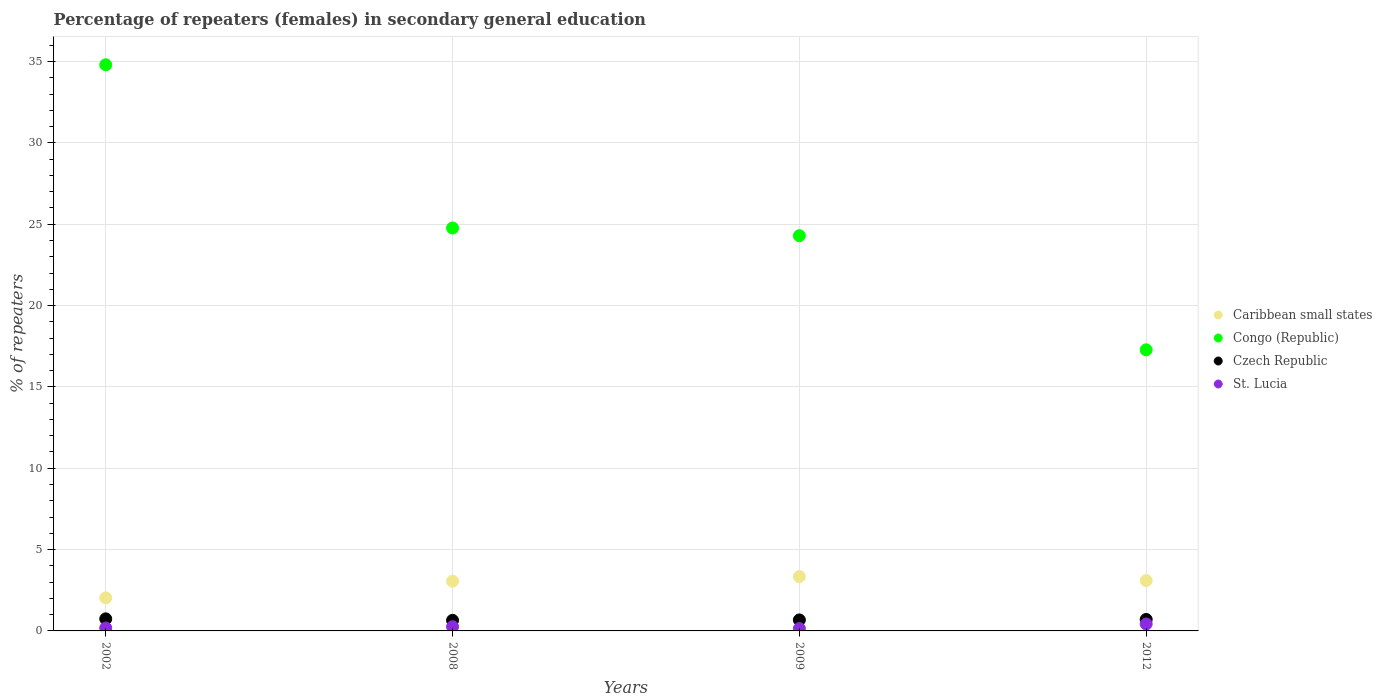How many different coloured dotlines are there?
Provide a succinct answer. 4. Is the number of dotlines equal to the number of legend labels?
Your answer should be very brief. Yes. What is the percentage of female repeaters in Czech Republic in 2012?
Your response must be concise. 0.7. Across all years, what is the maximum percentage of female repeaters in Caribbean small states?
Keep it short and to the point. 3.34. Across all years, what is the minimum percentage of female repeaters in Caribbean small states?
Make the answer very short. 2.03. What is the total percentage of female repeaters in Congo (Republic) in the graph?
Your response must be concise. 101.14. What is the difference between the percentage of female repeaters in St. Lucia in 2008 and that in 2009?
Keep it short and to the point. 0.11. What is the difference between the percentage of female repeaters in St. Lucia in 2008 and the percentage of female repeaters in Czech Republic in 2009?
Offer a terse response. -0.42. What is the average percentage of female repeaters in Czech Republic per year?
Ensure brevity in your answer.  0.69. In the year 2002, what is the difference between the percentage of female repeaters in St. Lucia and percentage of female repeaters in Czech Republic?
Keep it short and to the point. -0.56. In how many years, is the percentage of female repeaters in Czech Republic greater than 15 %?
Offer a very short reply. 0. What is the ratio of the percentage of female repeaters in Congo (Republic) in 2008 to that in 2009?
Keep it short and to the point. 1.02. Is the difference between the percentage of female repeaters in St. Lucia in 2009 and 2012 greater than the difference between the percentage of female repeaters in Czech Republic in 2009 and 2012?
Your response must be concise. No. What is the difference between the highest and the second highest percentage of female repeaters in Czech Republic?
Offer a very short reply. 0.04. What is the difference between the highest and the lowest percentage of female repeaters in Congo (Republic)?
Keep it short and to the point. 17.52. Does the percentage of female repeaters in Congo (Republic) monotonically increase over the years?
Your answer should be very brief. No. Is the percentage of female repeaters in Czech Republic strictly greater than the percentage of female repeaters in Caribbean small states over the years?
Ensure brevity in your answer.  No. Is the percentage of female repeaters in St. Lucia strictly less than the percentage of female repeaters in Caribbean small states over the years?
Your answer should be very brief. Yes. How many dotlines are there?
Offer a terse response. 4. How many years are there in the graph?
Provide a succinct answer. 4. Does the graph contain any zero values?
Offer a very short reply. No. Where does the legend appear in the graph?
Give a very brief answer. Center right. What is the title of the graph?
Your answer should be compact. Percentage of repeaters (females) in secondary general education. What is the label or title of the Y-axis?
Make the answer very short. % of repeaters. What is the % of repeaters of Caribbean small states in 2002?
Provide a succinct answer. 2.03. What is the % of repeaters of Congo (Republic) in 2002?
Your response must be concise. 34.8. What is the % of repeaters of Czech Republic in 2002?
Offer a very short reply. 0.74. What is the % of repeaters in St. Lucia in 2002?
Provide a succinct answer. 0.18. What is the % of repeaters in Caribbean small states in 2008?
Your answer should be compact. 3.06. What is the % of repeaters in Congo (Republic) in 2008?
Provide a succinct answer. 24.77. What is the % of repeaters of Czech Republic in 2008?
Provide a short and direct response. 0.65. What is the % of repeaters of St. Lucia in 2008?
Give a very brief answer. 0.26. What is the % of repeaters in Caribbean small states in 2009?
Provide a short and direct response. 3.34. What is the % of repeaters of Congo (Republic) in 2009?
Provide a succinct answer. 24.29. What is the % of repeaters of Czech Republic in 2009?
Your answer should be very brief. 0.68. What is the % of repeaters of St. Lucia in 2009?
Give a very brief answer. 0.15. What is the % of repeaters of Caribbean small states in 2012?
Your answer should be very brief. 3.1. What is the % of repeaters in Congo (Republic) in 2012?
Keep it short and to the point. 17.28. What is the % of repeaters of Czech Republic in 2012?
Offer a terse response. 0.7. What is the % of repeaters in St. Lucia in 2012?
Provide a succinct answer. 0.43. Across all years, what is the maximum % of repeaters of Caribbean small states?
Offer a terse response. 3.34. Across all years, what is the maximum % of repeaters of Congo (Republic)?
Ensure brevity in your answer.  34.8. Across all years, what is the maximum % of repeaters in Czech Republic?
Your response must be concise. 0.74. Across all years, what is the maximum % of repeaters in St. Lucia?
Make the answer very short. 0.43. Across all years, what is the minimum % of repeaters in Caribbean small states?
Offer a very short reply. 2.03. Across all years, what is the minimum % of repeaters of Congo (Republic)?
Offer a very short reply. 17.28. Across all years, what is the minimum % of repeaters in Czech Republic?
Your response must be concise. 0.65. Across all years, what is the minimum % of repeaters in St. Lucia?
Give a very brief answer. 0.15. What is the total % of repeaters of Caribbean small states in the graph?
Your answer should be compact. 11.52. What is the total % of repeaters of Congo (Republic) in the graph?
Make the answer very short. 101.14. What is the total % of repeaters of Czech Republic in the graph?
Offer a very short reply. 2.77. What is the total % of repeaters in St. Lucia in the graph?
Provide a succinct answer. 1.01. What is the difference between the % of repeaters in Caribbean small states in 2002 and that in 2008?
Make the answer very short. -1.02. What is the difference between the % of repeaters of Congo (Republic) in 2002 and that in 2008?
Provide a succinct answer. 10.03. What is the difference between the % of repeaters in Czech Republic in 2002 and that in 2008?
Your answer should be very brief. 0.09. What is the difference between the % of repeaters of St. Lucia in 2002 and that in 2008?
Provide a succinct answer. -0.08. What is the difference between the % of repeaters of Caribbean small states in 2002 and that in 2009?
Provide a short and direct response. -1.3. What is the difference between the % of repeaters of Congo (Republic) in 2002 and that in 2009?
Make the answer very short. 10.51. What is the difference between the % of repeaters in Czech Republic in 2002 and that in 2009?
Offer a terse response. 0.07. What is the difference between the % of repeaters of St. Lucia in 2002 and that in 2009?
Provide a succinct answer. 0.03. What is the difference between the % of repeaters of Caribbean small states in 2002 and that in 2012?
Give a very brief answer. -1.06. What is the difference between the % of repeaters in Congo (Republic) in 2002 and that in 2012?
Ensure brevity in your answer.  17.52. What is the difference between the % of repeaters of Czech Republic in 2002 and that in 2012?
Your answer should be very brief. 0.04. What is the difference between the % of repeaters in St. Lucia in 2002 and that in 2012?
Offer a very short reply. -0.25. What is the difference between the % of repeaters in Caribbean small states in 2008 and that in 2009?
Make the answer very short. -0.28. What is the difference between the % of repeaters in Congo (Republic) in 2008 and that in 2009?
Provide a short and direct response. 0.47. What is the difference between the % of repeaters in Czech Republic in 2008 and that in 2009?
Your answer should be very brief. -0.02. What is the difference between the % of repeaters of St. Lucia in 2008 and that in 2009?
Keep it short and to the point. 0.11. What is the difference between the % of repeaters of Caribbean small states in 2008 and that in 2012?
Ensure brevity in your answer.  -0.04. What is the difference between the % of repeaters of Congo (Republic) in 2008 and that in 2012?
Your response must be concise. 7.49. What is the difference between the % of repeaters of Czech Republic in 2008 and that in 2012?
Provide a short and direct response. -0.05. What is the difference between the % of repeaters of St. Lucia in 2008 and that in 2012?
Provide a short and direct response. -0.17. What is the difference between the % of repeaters in Caribbean small states in 2009 and that in 2012?
Keep it short and to the point. 0.24. What is the difference between the % of repeaters of Congo (Republic) in 2009 and that in 2012?
Make the answer very short. 7.01. What is the difference between the % of repeaters of Czech Republic in 2009 and that in 2012?
Your response must be concise. -0.03. What is the difference between the % of repeaters in St. Lucia in 2009 and that in 2012?
Offer a very short reply. -0.28. What is the difference between the % of repeaters in Caribbean small states in 2002 and the % of repeaters in Congo (Republic) in 2008?
Your answer should be very brief. -22.73. What is the difference between the % of repeaters in Caribbean small states in 2002 and the % of repeaters in Czech Republic in 2008?
Your response must be concise. 1.38. What is the difference between the % of repeaters of Caribbean small states in 2002 and the % of repeaters of St. Lucia in 2008?
Provide a short and direct response. 1.77. What is the difference between the % of repeaters of Congo (Republic) in 2002 and the % of repeaters of Czech Republic in 2008?
Your response must be concise. 34.15. What is the difference between the % of repeaters in Congo (Republic) in 2002 and the % of repeaters in St. Lucia in 2008?
Provide a succinct answer. 34.54. What is the difference between the % of repeaters in Czech Republic in 2002 and the % of repeaters in St. Lucia in 2008?
Your answer should be compact. 0.48. What is the difference between the % of repeaters in Caribbean small states in 2002 and the % of repeaters in Congo (Republic) in 2009?
Make the answer very short. -22.26. What is the difference between the % of repeaters in Caribbean small states in 2002 and the % of repeaters in Czech Republic in 2009?
Make the answer very short. 1.36. What is the difference between the % of repeaters of Caribbean small states in 2002 and the % of repeaters of St. Lucia in 2009?
Provide a succinct answer. 1.88. What is the difference between the % of repeaters of Congo (Republic) in 2002 and the % of repeaters of Czech Republic in 2009?
Offer a terse response. 34.12. What is the difference between the % of repeaters of Congo (Republic) in 2002 and the % of repeaters of St. Lucia in 2009?
Keep it short and to the point. 34.65. What is the difference between the % of repeaters of Czech Republic in 2002 and the % of repeaters of St. Lucia in 2009?
Provide a short and direct response. 0.59. What is the difference between the % of repeaters in Caribbean small states in 2002 and the % of repeaters in Congo (Republic) in 2012?
Your answer should be very brief. -15.25. What is the difference between the % of repeaters of Caribbean small states in 2002 and the % of repeaters of Czech Republic in 2012?
Make the answer very short. 1.33. What is the difference between the % of repeaters in Caribbean small states in 2002 and the % of repeaters in St. Lucia in 2012?
Ensure brevity in your answer.  1.61. What is the difference between the % of repeaters of Congo (Republic) in 2002 and the % of repeaters of Czech Republic in 2012?
Keep it short and to the point. 34.09. What is the difference between the % of repeaters in Congo (Republic) in 2002 and the % of repeaters in St. Lucia in 2012?
Your response must be concise. 34.37. What is the difference between the % of repeaters in Czech Republic in 2002 and the % of repeaters in St. Lucia in 2012?
Your answer should be compact. 0.32. What is the difference between the % of repeaters in Caribbean small states in 2008 and the % of repeaters in Congo (Republic) in 2009?
Your answer should be very brief. -21.24. What is the difference between the % of repeaters in Caribbean small states in 2008 and the % of repeaters in Czech Republic in 2009?
Offer a very short reply. 2.38. What is the difference between the % of repeaters in Caribbean small states in 2008 and the % of repeaters in St. Lucia in 2009?
Your answer should be compact. 2.91. What is the difference between the % of repeaters of Congo (Republic) in 2008 and the % of repeaters of Czech Republic in 2009?
Your answer should be compact. 24.09. What is the difference between the % of repeaters of Congo (Republic) in 2008 and the % of repeaters of St. Lucia in 2009?
Your response must be concise. 24.62. What is the difference between the % of repeaters of Czech Republic in 2008 and the % of repeaters of St. Lucia in 2009?
Offer a very short reply. 0.51. What is the difference between the % of repeaters of Caribbean small states in 2008 and the % of repeaters of Congo (Republic) in 2012?
Offer a very short reply. -14.22. What is the difference between the % of repeaters in Caribbean small states in 2008 and the % of repeaters in Czech Republic in 2012?
Provide a succinct answer. 2.35. What is the difference between the % of repeaters in Caribbean small states in 2008 and the % of repeaters in St. Lucia in 2012?
Your answer should be very brief. 2.63. What is the difference between the % of repeaters in Congo (Republic) in 2008 and the % of repeaters in Czech Republic in 2012?
Give a very brief answer. 24.06. What is the difference between the % of repeaters in Congo (Republic) in 2008 and the % of repeaters in St. Lucia in 2012?
Make the answer very short. 24.34. What is the difference between the % of repeaters in Czech Republic in 2008 and the % of repeaters in St. Lucia in 2012?
Your response must be concise. 0.23. What is the difference between the % of repeaters in Caribbean small states in 2009 and the % of repeaters in Congo (Republic) in 2012?
Make the answer very short. -13.94. What is the difference between the % of repeaters in Caribbean small states in 2009 and the % of repeaters in Czech Republic in 2012?
Offer a terse response. 2.63. What is the difference between the % of repeaters of Caribbean small states in 2009 and the % of repeaters of St. Lucia in 2012?
Make the answer very short. 2.91. What is the difference between the % of repeaters in Congo (Republic) in 2009 and the % of repeaters in Czech Republic in 2012?
Your answer should be compact. 23.59. What is the difference between the % of repeaters in Congo (Republic) in 2009 and the % of repeaters in St. Lucia in 2012?
Provide a succinct answer. 23.87. What is the difference between the % of repeaters of Czech Republic in 2009 and the % of repeaters of St. Lucia in 2012?
Provide a succinct answer. 0.25. What is the average % of repeaters in Caribbean small states per year?
Offer a very short reply. 2.88. What is the average % of repeaters of Congo (Republic) per year?
Make the answer very short. 25.28. What is the average % of repeaters in Czech Republic per year?
Provide a short and direct response. 0.69. What is the average % of repeaters of St. Lucia per year?
Provide a short and direct response. 0.25. In the year 2002, what is the difference between the % of repeaters in Caribbean small states and % of repeaters in Congo (Republic)?
Provide a succinct answer. -32.77. In the year 2002, what is the difference between the % of repeaters in Caribbean small states and % of repeaters in Czech Republic?
Give a very brief answer. 1.29. In the year 2002, what is the difference between the % of repeaters of Caribbean small states and % of repeaters of St. Lucia?
Provide a short and direct response. 1.85. In the year 2002, what is the difference between the % of repeaters in Congo (Republic) and % of repeaters in Czech Republic?
Ensure brevity in your answer.  34.06. In the year 2002, what is the difference between the % of repeaters of Congo (Republic) and % of repeaters of St. Lucia?
Ensure brevity in your answer.  34.62. In the year 2002, what is the difference between the % of repeaters in Czech Republic and % of repeaters in St. Lucia?
Offer a very short reply. 0.56. In the year 2008, what is the difference between the % of repeaters of Caribbean small states and % of repeaters of Congo (Republic)?
Your response must be concise. -21.71. In the year 2008, what is the difference between the % of repeaters of Caribbean small states and % of repeaters of Czech Republic?
Ensure brevity in your answer.  2.4. In the year 2008, what is the difference between the % of repeaters in Caribbean small states and % of repeaters in St. Lucia?
Your answer should be compact. 2.8. In the year 2008, what is the difference between the % of repeaters in Congo (Republic) and % of repeaters in Czech Republic?
Offer a very short reply. 24.11. In the year 2008, what is the difference between the % of repeaters of Congo (Republic) and % of repeaters of St. Lucia?
Your answer should be very brief. 24.51. In the year 2008, what is the difference between the % of repeaters of Czech Republic and % of repeaters of St. Lucia?
Make the answer very short. 0.39. In the year 2009, what is the difference between the % of repeaters in Caribbean small states and % of repeaters in Congo (Republic)?
Make the answer very short. -20.96. In the year 2009, what is the difference between the % of repeaters in Caribbean small states and % of repeaters in Czech Republic?
Provide a short and direct response. 2.66. In the year 2009, what is the difference between the % of repeaters of Caribbean small states and % of repeaters of St. Lucia?
Offer a very short reply. 3.19. In the year 2009, what is the difference between the % of repeaters of Congo (Republic) and % of repeaters of Czech Republic?
Keep it short and to the point. 23.62. In the year 2009, what is the difference between the % of repeaters of Congo (Republic) and % of repeaters of St. Lucia?
Your response must be concise. 24.15. In the year 2009, what is the difference between the % of repeaters in Czech Republic and % of repeaters in St. Lucia?
Make the answer very short. 0.53. In the year 2012, what is the difference between the % of repeaters of Caribbean small states and % of repeaters of Congo (Republic)?
Offer a very short reply. -14.18. In the year 2012, what is the difference between the % of repeaters in Caribbean small states and % of repeaters in Czech Republic?
Your answer should be very brief. 2.39. In the year 2012, what is the difference between the % of repeaters of Caribbean small states and % of repeaters of St. Lucia?
Ensure brevity in your answer.  2.67. In the year 2012, what is the difference between the % of repeaters in Congo (Republic) and % of repeaters in Czech Republic?
Make the answer very short. 16.57. In the year 2012, what is the difference between the % of repeaters of Congo (Republic) and % of repeaters of St. Lucia?
Provide a succinct answer. 16.85. In the year 2012, what is the difference between the % of repeaters of Czech Republic and % of repeaters of St. Lucia?
Provide a succinct answer. 0.28. What is the ratio of the % of repeaters in Caribbean small states in 2002 to that in 2008?
Offer a terse response. 0.66. What is the ratio of the % of repeaters of Congo (Republic) in 2002 to that in 2008?
Your answer should be compact. 1.41. What is the ratio of the % of repeaters of Czech Republic in 2002 to that in 2008?
Your answer should be very brief. 1.14. What is the ratio of the % of repeaters in St. Lucia in 2002 to that in 2008?
Make the answer very short. 0.69. What is the ratio of the % of repeaters in Caribbean small states in 2002 to that in 2009?
Offer a very short reply. 0.61. What is the ratio of the % of repeaters in Congo (Republic) in 2002 to that in 2009?
Offer a very short reply. 1.43. What is the ratio of the % of repeaters in Czech Republic in 2002 to that in 2009?
Your answer should be compact. 1.1. What is the ratio of the % of repeaters of St. Lucia in 2002 to that in 2009?
Give a very brief answer. 1.22. What is the ratio of the % of repeaters of Caribbean small states in 2002 to that in 2012?
Provide a succinct answer. 0.66. What is the ratio of the % of repeaters of Congo (Republic) in 2002 to that in 2012?
Your response must be concise. 2.01. What is the ratio of the % of repeaters in Czech Republic in 2002 to that in 2012?
Ensure brevity in your answer.  1.05. What is the ratio of the % of repeaters of St. Lucia in 2002 to that in 2012?
Provide a succinct answer. 0.42. What is the ratio of the % of repeaters in Caribbean small states in 2008 to that in 2009?
Your answer should be compact. 0.92. What is the ratio of the % of repeaters in Congo (Republic) in 2008 to that in 2009?
Give a very brief answer. 1.02. What is the ratio of the % of repeaters in Czech Republic in 2008 to that in 2009?
Your answer should be compact. 0.97. What is the ratio of the % of repeaters in St. Lucia in 2008 to that in 2009?
Keep it short and to the point. 1.77. What is the ratio of the % of repeaters in Caribbean small states in 2008 to that in 2012?
Ensure brevity in your answer.  0.99. What is the ratio of the % of repeaters of Congo (Republic) in 2008 to that in 2012?
Provide a short and direct response. 1.43. What is the ratio of the % of repeaters in Czech Republic in 2008 to that in 2012?
Make the answer very short. 0.93. What is the ratio of the % of repeaters in St. Lucia in 2008 to that in 2012?
Offer a very short reply. 0.61. What is the ratio of the % of repeaters in Caribbean small states in 2009 to that in 2012?
Keep it short and to the point. 1.08. What is the ratio of the % of repeaters in Congo (Republic) in 2009 to that in 2012?
Provide a short and direct response. 1.41. What is the ratio of the % of repeaters of Czech Republic in 2009 to that in 2012?
Offer a very short reply. 0.96. What is the ratio of the % of repeaters in St. Lucia in 2009 to that in 2012?
Offer a very short reply. 0.35. What is the difference between the highest and the second highest % of repeaters of Caribbean small states?
Make the answer very short. 0.24. What is the difference between the highest and the second highest % of repeaters of Congo (Republic)?
Offer a terse response. 10.03. What is the difference between the highest and the second highest % of repeaters in Czech Republic?
Provide a succinct answer. 0.04. What is the difference between the highest and the second highest % of repeaters of St. Lucia?
Make the answer very short. 0.17. What is the difference between the highest and the lowest % of repeaters in Caribbean small states?
Make the answer very short. 1.3. What is the difference between the highest and the lowest % of repeaters in Congo (Republic)?
Give a very brief answer. 17.52. What is the difference between the highest and the lowest % of repeaters in Czech Republic?
Your response must be concise. 0.09. What is the difference between the highest and the lowest % of repeaters of St. Lucia?
Provide a succinct answer. 0.28. 